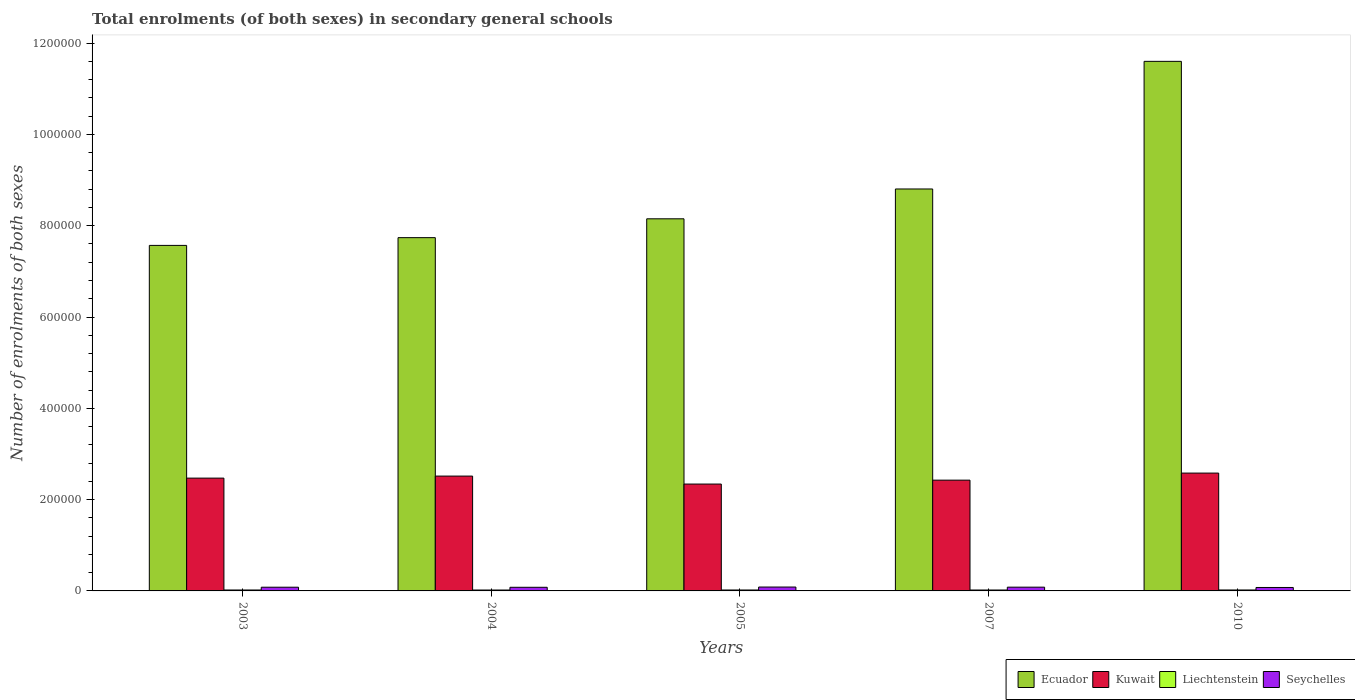How many different coloured bars are there?
Provide a short and direct response. 4. How many groups of bars are there?
Offer a very short reply. 5. Are the number of bars per tick equal to the number of legend labels?
Your response must be concise. Yes. How many bars are there on the 5th tick from the right?
Offer a terse response. 4. What is the label of the 2nd group of bars from the left?
Provide a succinct answer. 2004. In how many cases, is the number of bars for a given year not equal to the number of legend labels?
Give a very brief answer. 0. What is the number of enrolments in secondary schools in Kuwait in 2005?
Offer a terse response. 2.34e+05. Across all years, what is the maximum number of enrolments in secondary schools in Kuwait?
Make the answer very short. 2.58e+05. Across all years, what is the minimum number of enrolments in secondary schools in Seychelles?
Your answer should be compact. 7554. In which year was the number of enrolments in secondary schools in Seychelles maximum?
Offer a very short reply. 2005. In which year was the number of enrolments in secondary schools in Ecuador minimum?
Provide a short and direct response. 2003. What is the total number of enrolments in secondary schools in Liechtenstein in the graph?
Make the answer very short. 1.01e+04. What is the difference between the number of enrolments in secondary schools in Ecuador in 2003 and that in 2010?
Ensure brevity in your answer.  -4.03e+05. What is the difference between the number of enrolments in secondary schools in Kuwait in 2010 and the number of enrolments in secondary schools in Seychelles in 2005?
Make the answer very short. 2.50e+05. What is the average number of enrolments in secondary schools in Seychelles per year?
Offer a very short reply. 8076.2. In the year 2010, what is the difference between the number of enrolments in secondary schools in Ecuador and number of enrolments in secondary schools in Kuwait?
Keep it short and to the point. 9.02e+05. What is the ratio of the number of enrolments in secondary schools in Liechtenstein in 2003 to that in 2005?
Keep it short and to the point. 0.99. Is the difference between the number of enrolments in secondary schools in Ecuador in 2005 and 2007 greater than the difference between the number of enrolments in secondary schools in Kuwait in 2005 and 2007?
Your response must be concise. No. What is the difference between the highest and the second highest number of enrolments in secondary schools in Liechtenstein?
Your answer should be very brief. 19. What is the difference between the highest and the lowest number of enrolments in secondary schools in Ecuador?
Make the answer very short. 4.03e+05. Is the sum of the number of enrolments in secondary schools in Liechtenstein in 2003 and 2005 greater than the maximum number of enrolments in secondary schools in Kuwait across all years?
Keep it short and to the point. No. Is it the case that in every year, the sum of the number of enrolments in secondary schools in Ecuador and number of enrolments in secondary schools in Seychelles is greater than the sum of number of enrolments in secondary schools in Liechtenstein and number of enrolments in secondary schools in Kuwait?
Keep it short and to the point. Yes. What does the 4th bar from the left in 2010 represents?
Offer a terse response. Seychelles. What does the 2nd bar from the right in 2005 represents?
Give a very brief answer. Liechtenstein. Are all the bars in the graph horizontal?
Your response must be concise. No. Does the graph contain grids?
Ensure brevity in your answer.  No. Where does the legend appear in the graph?
Offer a terse response. Bottom right. How many legend labels are there?
Provide a short and direct response. 4. How are the legend labels stacked?
Give a very brief answer. Horizontal. What is the title of the graph?
Make the answer very short. Total enrolments (of both sexes) in secondary general schools. What is the label or title of the X-axis?
Offer a terse response. Years. What is the label or title of the Y-axis?
Make the answer very short. Number of enrolments of both sexes. What is the Number of enrolments of both sexes of Ecuador in 2003?
Keep it short and to the point. 7.57e+05. What is the Number of enrolments of both sexes in Kuwait in 2003?
Provide a short and direct response. 2.47e+05. What is the Number of enrolments of both sexes of Liechtenstein in 2003?
Make the answer very short. 2028. What is the Number of enrolments of both sexes in Seychelles in 2003?
Offer a very short reply. 8137. What is the Number of enrolments of both sexes of Ecuador in 2004?
Make the answer very short. 7.74e+05. What is the Number of enrolments of both sexes in Kuwait in 2004?
Give a very brief answer. 2.52e+05. What is the Number of enrolments of both sexes in Liechtenstein in 2004?
Your response must be concise. 1975. What is the Number of enrolments of both sexes in Seychelles in 2004?
Your response must be concise. 7962. What is the Number of enrolments of both sexes in Ecuador in 2005?
Ensure brevity in your answer.  8.15e+05. What is the Number of enrolments of both sexes in Kuwait in 2005?
Your response must be concise. 2.34e+05. What is the Number of enrolments of both sexes in Liechtenstein in 2005?
Offer a very short reply. 2048. What is the Number of enrolments of both sexes in Seychelles in 2005?
Offer a terse response. 8501. What is the Number of enrolments of both sexes in Ecuador in 2007?
Provide a succinct answer. 8.80e+05. What is the Number of enrolments of both sexes in Kuwait in 2007?
Your answer should be compact. 2.43e+05. What is the Number of enrolments of both sexes of Liechtenstein in 2007?
Your answer should be compact. 2014. What is the Number of enrolments of both sexes of Seychelles in 2007?
Offer a very short reply. 8227. What is the Number of enrolments of both sexes of Ecuador in 2010?
Provide a succinct answer. 1.16e+06. What is the Number of enrolments of both sexes of Kuwait in 2010?
Your answer should be compact. 2.58e+05. What is the Number of enrolments of both sexes of Liechtenstein in 2010?
Give a very brief answer. 2067. What is the Number of enrolments of both sexes in Seychelles in 2010?
Your answer should be compact. 7554. Across all years, what is the maximum Number of enrolments of both sexes of Ecuador?
Keep it short and to the point. 1.16e+06. Across all years, what is the maximum Number of enrolments of both sexes in Kuwait?
Your response must be concise. 2.58e+05. Across all years, what is the maximum Number of enrolments of both sexes in Liechtenstein?
Provide a succinct answer. 2067. Across all years, what is the maximum Number of enrolments of both sexes in Seychelles?
Your answer should be very brief. 8501. Across all years, what is the minimum Number of enrolments of both sexes in Ecuador?
Provide a succinct answer. 7.57e+05. Across all years, what is the minimum Number of enrolments of both sexes of Kuwait?
Make the answer very short. 2.34e+05. Across all years, what is the minimum Number of enrolments of both sexes of Liechtenstein?
Offer a terse response. 1975. Across all years, what is the minimum Number of enrolments of both sexes of Seychelles?
Offer a very short reply. 7554. What is the total Number of enrolments of both sexes of Ecuador in the graph?
Give a very brief answer. 4.39e+06. What is the total Number of enrolments of both sexes of Kuwait in the graph?
Provide a succinct answer. 1.23e+06. What is the total Number of enrolments of both sexes in Liechtenstein in the graph?
Give a very brief answer. 1.01e+04. What is the total Number of enrolments of both sexes of Seychelles in the graph?
Your answer should be compact. 4.04e+04. What is the difference between the Number of enrolments of both sexes in Ecuador in 2003 and that in 2004?
Keep it short and to the point. -1.70e+04. What is the difference between the Number of enrolments of both sexes in Kuwait in 2003 and that in 2004?
Keep it short and to the point. -4450. What is the difference between the Number of enrolments of both sexes of Liechtenstein in 2003 and that in 2004?
Keep it short and to the point. 53. What is the difference between the Number of enrolments of both sexes of Seychelles in 2003 and that in 2004?
Make the answer very short. 175. What is the difference between the Number of enrolments of both sexes in Ecuador in 2003 and that in 2005?
Keep it short and to the point. -5.83e+04. What is the difference between the Number of enrolments of both sexes in Kuwait in 2003 and that in 2005?
Provide a short and direct response. 1.30e+04. What is the difference between the Number of enrolments of both sexes in Liechtenstein in 2003 and that in 2005?
Ensure brevity in your answer.  -20. What is the difference between the Number of enrolments of both sexes of Seychelles in 2003 and that in 2005?
Your answer should be very brief. -364. What is the difference between the Number of enrolments of both sexes of Ecuador in 2003 and that in 2007?
Provide a short and direct response. -1.24e+05. What is the difference between the Number of enrolments of both sexes of Kuwait in 2003 and that in 2007?
Provide a succinct answer. 4472. What is the difference between the Number of enrolments of both sexes in Seychelles in 2003 and that in 2007?
Your answer should be very brief. -90. What is the difference between the Number of enrolments of both sexes of Ecuador in 2003 and that in 2010?
Your answer should be compact. -4.03e+05. What is the difference between the Number of enrolments of both sexes of Kuwait in 2003 and that in 2010?
Ensure brevity in your answer.  -1.10e+04. What is the difference between the Number of enrolments of both sexes of Liechtenstein in 2003 and that in 2010?
Make the answer very short. -39. What is the difference between the Number of enrolments of both sexes in Seychelles in 2003 and that in 2010?
Your answer should be very brief. 583. What is the difference between the Number of enrolments of both sexes in Ecuador in 2004 and that in 2005?
Your answer should be compact. -4.13e+04. What is the difference between the Number of enrolments of both sexes in Kuwait in 2004 and that in 2005?
Ensure brevity in your answer.  1.75e+04. What is the difference between the Number of enrolments of both sexes in Liechtenstein in 2004 and that in 2005?
Your response must be concise. -73. What is the difference between the Number of enrolments of both sexes in Seychelles in 2004 and that in 2005?
Offer a very short reply. -539. What is the difference between the Number of enrolments of both sexes of Ecuador in 2004 and that in 2007?
Provide a succinct answer. -1.07e+05. What is the difference between the Number of enrolments of both sexes of Kuwait in 2004 and that in 2007?
Provide a short and direct response. 8922. What is the difference between the Number of enrolments of both sexes of Liechtenstein in 2004 and that in 2007?
Give a very brief answer. -39. What is the difference between the Number of enrolments of both sexes in Seychelles in 2004 and that in 2007?
Provide a short and direct response. -265. What is the difference between the Number of enrolments of both sexes in Ecuador in 2004 and that in 2010?
Keep it short and to the point. -3.86e+05. What is the difference between the Number of enrolments of both sexes of Kuwait in 2004 and that in 2010?
Your response must be concise. -6545. What is the difference between the Number of enrolments of both sexes of Liechtenstein in 2004 and that in 2010?
Offer a very short reply. -92. What is the difference between the Number of enrolments of both sexes in Seychelles in 2004 and that in 2010?
Your response must be concise. 408. What is the difference between the Number of enrolments of both sexes of Ecuador in 2005 and that in 2007?
Your answer should be very brief. -6.53e+04. What is the difference between the Number of enrolments of both sexes of Kuwait in 2005 and that in 2007?
Keep it short and to the point. -8558. What is the difference between the Number of enrolments of both sexes of Liechtenstein in 2005 and that in 2007?
Provide a short and direct response. 34. What is the difference between the Number of enrolments of both sexes in Seychelles in 2005 and that in 2007?
Ensure brevity in your answer.  274. What is the difference between the Number of enrolments of both sexes in Ecuador in 2005 and that in 2010?
Ensure brevity in your answer.  -3.45e+05. What is the difference between the Number of enrolments of both sexes in Kuwait in 2005 and that in 2010?
Provide a short and direct response. -2.40e+04. What is the difference between the Number of enrolments of both sexes of Liechtenstein in 2005 and that in 2010?
Your response must be concise. -19. What is the difference between the Number of enrolments of both sexes in Seychelles in 2005 and that in 2010?
Ensure brevity in your answer.  947. What is the difference between the Number of enrolments of both sexes of Ecuador in 2007 and that in 2010?
Make the answer very short. -2.80e+05. What is the difference between the Number of enrolments of both sexes in Kuwait in 2007 and that in 2010?
Provide a short and direct response. -1.55e+04. What is the difference between the Number of enrolments of both sexes of Liechtenstein in 2007 and that in 2010?
Offer a very short reply. -53. What is the difference between the Number of enrolments of both sexes in Seychelles in 2007 and that in 2010?
Your answer should be very brief. 673. What is the difference between the Number of enrolments of both sexes of Ecuador in 2003 and the Number of enrolments of both sexes of Kuwait in 2004?
Your answer should be compact. 5.05e+05. What is the difference between the Number of enrolments of both sexes in Ecuador in 2003 and the Number of enrolments of both sexes in Liechtenstein in 2004?
Give a very brief answer. 7.55e+05. What is the difference between the Number of enrolments of both sexes in Ecuador in 2003 and the Number of enrolments of both sexes in Seychelles in 2004?
Give a very brief answer. 7.49e+05. What is the difference between the Number of enrolments of both sexes in Kuwait in 2003 and the Number of enrolments of both sexes in Liechtenstein in 2004?
Keep it short and to the point. 2.45e+05. What is the difference between the Number of enrolments of both sexes in Kuwait in 2003 and the Number of enrolments of both sexes in Seychelles in 2004?
Provide a short and direct response. 2.39e+05. What is the difference between the Number of enrolments of both sexes of Liechtenstein in 2003 and the Number of enrolments of both sexes of Seychelles in 2004?
Give a very brief answer. -5934. What is the difference between the Number of enrolments of both sexes of Ecuador in 2003 and the Number of enrolments of both sexes of Kuwait in 2005?
Offer a terse response. 5.23e+05. What is the difference between the Number of enrolments of both sexes of Ecuador in 2003 and the Number of enrolments of both sexes of Liechtenstein in 2005?
Keep it short and to the point. 7.55e+05. What is the difference between the Number of enrolments of both sexes in Ecuador in 2003 and the Number of enrolments of both sexes in Seychelles in 2005?
Give a very brief answer. 7.48e+05. What is the difference between the Number of enrolments of both sexes of Kuwait in 2003 and the Number of enrolments of both sexes of Liechtenstein in 2005?
Provide a succinct answer. 2.45e+05. What is the difference between the Number of enrolments of both sexes of Kuwait in 2003 and the Number of enrolments of both sexes of Seychelles in 2005?
Your answer should be very brief. 2.39e+05. What is the difference between the Number of enrolments of both sexes of Liechtenstein in 2003 and the Number of enrolments of both sexes of Seychelles in 2005?
Your response must be concise. -6473. What is the difference between the Number of enrolments of both sexes in Ecuador in 2003 and the Number of enrolments of both sexes in Kuwait in 2007?
Ensure brevity in your answer.  5.14e+05. What is the difference between the Number of enrolments of both sexes of Ecuador in 2003 and the Number of enrolments of both sexes of Liechtenstein in 2007?
Give a very brief answer. 7.55e+05. What is the difference between the Number of enrolments of both sexes of Ecuador in 2003 and the Number of enrolments of both sexes of Seychelles in 2007?
Offer a very short reply. 7.49e+05. What is the difference between the Number of enrolments of both sexes in Kuwait in 2003 and the Number of enrolments of both sexes in Liechtenstein in 2007?
Ensure brevity in your answer.  2.45e+05. What is the difference between the Number of enrolments of both sexes in Kuwait in 2003 and the Number of enrolments of both sexes in Seychelles in 2007?
Keep it short and to the point. 2.39e+05. What is the difference between the Number of enrolments of both sexes of Liechtenstein in 2003 and the Number of enrolments of both sexes of Seychelles in 2007?
Ensure brevity in your answer.  -6199. What is the difference between the Number of enrolments of both sexes in Ecuador in 2003 and the Number of enrolments of both sexes in Kuwait in 2010?
Your answer should be compact. 4.99e+05. What is the difference between the Number of enrolments of both sexes of Ecuador in 2003 and the Number of enrolments of both sexes of Liechtenstein in 2010?
Keep it short and to the point. 7.55e+05. What is the difference between the Number of enrolments of both sexes in Ecuador in 2003 and the Number of enrolments of both sexes in Seychelles in 2010?
Provide a short and direct response. 7.49e+05. What is the difference between the Number of enrolments of both sexes of Kuwait in 2003 and the Number of enrolments of both sexes of Liechtenstein in 2010?
Your answer should be compact. 2.45e+05. What is the difference between the Number of enrolments of both sexes of Kuwait in 2003 and the Number of enrolments of both sexes of Seychelles in 2010?
Provide a succinct answer. 2.40e+05. What is the difference between the Number of enrolments of both sexes in Liechtenstein in 2003 and the Number of enrolments of both sexes in Seychelles in 2010?
Ensure brevity in your answer.  -5526. What is the difference between the Number of enrolments of both sexes in Ecuador in 2004 and the Number of enrolments of both sexes in Kuwait in 2005?
Provide a succinct answer. 5.40e+05. What is the difference between the Number of enrolments of both sexes in Ecuador in 2004 and the Number of enrolments of both sexes in Liechtenstein in 2005?
Offer a very short reply. 7.72e+05. What is the difference between the Number of enrolments of both sexes of Ecuador in 2004 and the Number of enrolments of both sexes of Seychelles in 2005?
Provide a short and direct response. 7.65e+05. What is the difference between the Number of enrolments of both sexes in Kuwait in 2004 and the Number of enrolments of both sexes in Liechtenstein in 2005?
Provide a short and direct response. 2.50e+05. What is the difference between the Number of enrolments of both sexes of Kuwait in 2004 and the Number of enrolments of both sexes of Seychelles in 2005?
Provide a succinct answer. 2.43e+05. What is the difference between the Number of enrolments of both sexes in Liechtenstein in 2004 and the Number of enrolments of both sexes in Seychelles in 2005?
Give a very brief answer. -6526. What is the difference between the Number of enrolments of both sexes in Ecuador in 2004 and the Number of enrolments of both sexes in Kuwait in 2007?
Offer a terse response. 5.31e+05. What is the difference between the Number of enrolments of both sexes in Ecuador in 2004 and the Number of enrolments of both sexes in Liechtenstein in 2007?
Offer a very short reply. 7.72e+05. What is the difference between the Number of enrolments of both sexes in Ecuador in 2004 and the Number of enrolments of both sexes in Seychelles in 2007?
Your answer should be compact. 7.66e+05. What is the difference between the Number of enrolments of both sexes in Kuwait in 2004 and the Number of enrolments of both sexes in Liechtenstein in 2007?
Ensure brevity in your answer.  2.50e+05. What is the difference between the Number of enrolments of both sexes of Kuwait in 2004 and the Number of enrolments of both sexes of Seychelles in 2007?
Your answer should be very brief. 2.43e+05. What is the difference between the Number of enrolments of both sexes in Liechtenstein in 2004 and the Number of enrolments of both sexes in Seychelles in 2007?
Offer a terse response. -6252. What is the difference between the Number of enrolments of both sexes of Ecuador in 2004 and the Number of enrolments of both sexes of Kuwait in 2010?
Offer a terse response. 5.16e+05. What is the difference between the Number of enrolments of both sexes in Ecuador in 2004 and the Number of enrolments of both sexes in Liechtenstein in 2010?
Ensure brevity in your answer.  7.72e+05. What is the difference between the Number of enrolments of both sexes in Ecuador in 2004 and the Number of enrolments of both sexes in Seychelles in 2010?
Make the answer very short. 7.66e+05. What is the difference between the Number of enrolments of both sexes of Kuwait in 2004 and the Number of enrolments of both sexes of Liechtenstein in 2010?
Ensure brevity in your answer.  2.49e+05. What is the difference between the Number of enrolments of both sexes of Kuwait in 2004 and the Number of enrolments of both sexes of Seychelles in 2010?
Provide a succinct answer. 2.44e+05. What is the difference between the Number of enrolments of both sexes of Liechtenstein in 2004 and the Number of enrolments of both sexes of Seychelles in 2010?
Offer a very short reply. -5579. What is the difference between the Number of enrolments of both sexes of Ecuador in 2005 and the Number of enrolments of both sexes of Kuwait in 2007?
Your answer should be compact. 5.72e+05. What is the difference between the Number of enrolments of both sexes of Ecuador in 2005 and the Number of enrolments of both sexes of Liechtenstein in 2007?
Provide a short and direct response. 8.13e+05. What is the difference between the Number of enrolments of both sexes of Ecuador in 2005 and the Number of enrolments of both sexes of Seychelles in 2007?
Ensure brevity in your answer.  8.07e+05. What is the difference between the Number of enrolments of both sexes in Kuwait in 2005 and the Number of enrolments of both sexes in Liechtenstein in 2007?
Offer a terse response. 2.32e+05. What is the difference between the Number of enrolments of both sexes in Kuwait in 2005 and the Number of enrolments of both sexes in Seychelles in 2007?
Ensure brevity in your answer.  2.26e+05. What is the difference between the Number of enrolments of both sexes in Liechtenstein in 2005 and the Number of enrolments of both sexes in Seychelles in 2007?
Your answer should be compact. -6179. What is the difference between the Number of enrolments of both sexes in Ecuador in 2005 and the Number of enrolments of both sexes in Kuwait in 2010?
Offer a very short reply. 5.57e+05. What is the difference between the Number of enrolments of both sexes of Ecuador in 2005 and the Number of enrolments of both sexes of Liechtenstein in 2010?
Give a very brief answer. 8.13e+05. What is the difference between the Number of enrolments of both sexes in Ecuador in 2005 and the Number of enrolments of both sexes in Seychelles in 2010?
Offer a terse response. 8.08e+05. What is the difference between the Number of enrolments of both sexes of Kuwait in 2005 and the Number of enrolments of both sexes of Liechtenstein in 2010?
Offer a terse response. 2.32e+05. What is the difference between the Number of enrolments of both sexes of Kuwait in 2005 and the Number of enrolments of both sexes of Seychelles in 2010?
Offer a terse response. 2.27e+05. What is the difference between the Number of enrolments of both sexes of Liechtenstein in 2005 and the Number of enrolments of both sexes of Seychelles in 2010?
Provide a succinct answer. -5506. What is the difference between the Number of enrolments of both sexes of Ecuador in 2007 and the Number of enrolments of both sexes of Kuwait in 2010?
Ensure brevity in your answer.  6.22e+05. What is the difference between the Number of enrolments of both sexes in Ecuador in 2007 and the Number of enrolments of both sexes in Liechtenstein in 2010?
Provide a short and direct response. 8.78e+05. What is the difference between the Number of enrolments of both sexes in Ecuador in 2007 and the Number of enrolments of both sexes in Seychelles in 2010?
Ensure brevity in your answer.  8.73e+05. What is the difference between the Number of enrolments of both sexes in Kuwait in 2007 and the Number of enrolments of both sexes in Liechtenstein in 2010?
Keep it short and to the point. 2.41e+05. What is the difference between the Number of enrolments of both sexes in Kuwait in 2007 and the Number of enrolments of both sexes in Seychelles in 2010?
Your answer should be very brief. 2.35e+05. What is the difference between the Number of enrolments of both sexes in Liechtenstein in 2007 and the Number of enrolments of both sexes in Seychelles in 2010?
Your response must be concise. -5540. What is the average Number of enrolments of both sexes in Ecuador per year?
Keep it short and to the point. 8.77e+05. What is the average Number of enrolments of both sexes of Kuwait per year?
Offer a very short reply. 2.47e+05. What is the average Number of enrolments of both sexes of Liechtenstein per year?
Your answer should be compact. 2026.4. What is the average Number of enrolments of both sexes of Seychelles per year?
Your response must be concise. 8076.2. In the year 2003, what is the difference between the Number of enrolments of both sexes of Ecuador and Number of enrolments of both sexes of Kuwait?
Your response must be concise. 5.10e+05. In the year 2003, what is the difference between the Number of enrolments of both sexes of Ecuador and Number of enrolments of both sexes of Liechtenstein?
Your answer should be very brief. 7.55e+05. In the year 2003, what is the difference between the Number of enrolments of both sexes of Ecuador and Number of enrolments of both sexes of Seychelles?
Provide a succinct answer. 7.49e+05. In the year 2003, what is the difference between the Number of enrolments of both sexes in Kuwait and Number of enrolments of both sexes in Liechtenstein?
Your answer should be compact. 2.45e+05. In the year 2003, what is the difference between the Number of enrolments of both sexes in Kuwait and Number of enrolments of both sexes in Seychelles?
Give a very brief answer. 2.39e+05. In the year 2003, what is the difference between the Number of enrolments of both sexes in Liechtenstein and Number of enrolments of both sexes in Seychelles?
Your response must be concise. -6109. In the year 2004, what is the difference between the Number of enrolments of both sexes in Ecuador and Number of enrolments of both sexes in Kuwait?
Keep it short and to the point. 5.22e+05. In the year 2004, what is the difference between the Number of enrolments of both sexes of Ecuador and Number of enrolments of both sexes of Liechtenstein?
Make the answer very short. 7.72e+05. In the year 2004, what is the difference between the Number of enrolments of both sexes of Ecuador and Number of enrolments of both sexes of Seychelles?
Offer a terse response. 7.66e+05. In the year 2004, what is the difference between the Number of enrolments of both sexes of Kuwait and Number of enrolments of both sexes of Liechtenstein?
Ensure brevity in your answer.  2.50e+05. In the year 2004, what is the difference between the Number of enrolments of both sexes of Kuwait and Number of enrolments of both sexes of Seychelles?
Offer a terse response. 2.44e+05. In the year 2004, what is the difference between the Number of enrolments of both sexes in Liechtenstein and Number of enrolments of both sexes in Seychelles?
Ensure brevity in your answer.  -5987. In the year 2005, what is the difference between the Number of enrolments of both sexes in Ecuador and Number of enrolments of both sexes in Kuwait?
Your answer should be very brief. 5.81e+05. In the year 2005, what is the difference between the Number of enrolments of both sexes of Ecuador and Number of enrolments of both sexes of Liechtenstein?
Provide a short and direct response. 8.13e+05. In the year 2005, what is the difference between the Number of enrolments of both sexes in Ecuador and Number of enrolments of both sexes in Seychelles?
Make the answer very short. 8.07e+05. In the year 2005, what is the difference between the Number of enrolments of both sexes of Kuwait and Number of enrolments of both sexes of Liechtenstein?
Ensure brevity in your answer.  2.32e+05. In the year 2005, what is the difference between the Number of enrolments of both sexes in Kuwait and Number of enrolments of both sexes in Seychelles?
Offer a terse response. 2.26e+05. In the year 2005, what is the difference between the Number of enrolments of both sexes in Liechtenstein and Number of enrolments of both sexes in Seychelles?
Your answer should be very brief. -6453. In the year 2007, what is the difference between the Number of enrolments of both sexes in Ecuador and Number of enrolments of both sexes in Kuwait?
Give a very brief answer. 6.38e+05. In the year 2007, what is the difference between the Number of enrolments of both sexes in Ecuador and Number of enrolments of both sexes in Liechtenstein?
Give a very brief answer. 8.78e+05. In the year 2007, what is the difference between the Number of enrolments of both sexes of Ecuador and Number of enrolments of both sexes of Seychelles?
Give a very brief answer. 8.72e+05. In the year 2007, what is the difference between the Number of enrolments of both sexes of Kuwait and Number of enrolments of both sexes of Liechtenstein?
Your response must be concise. 2.41e+05. In the year 2007, what is the difference between the Number of enrolments of both sexes in Kuwait and Number of enrolments of both sexes in Seychelles?
Ensure brevity in your answer.  2.34e+05. In the year 2007, what is the difference between the Number of enrolments of both sexes in Liechtenstein and Number of enrolments of both sexes in Seychelles?
Your answer should be compact. -6213. In the year 2010, what is the difference between the Number of enrolments of both sexes of Ecuador and Number of enrolments of both sexes of Kuwait?
Keep it short and to the point. 9.02e+05. In the year 2010, what is the difference between the Number of enrolments of both sexes of Ecuador and Number of enrolments of both sexes of Liechtenstein?
Provide a short and direct response. 1.16e+06. In the year 2010, what is the difference between the Number of enrolments of both sexes in Ecuador and Number of enrolments of both sexes in Seychelles?
Provide a short and direct response. 1.15e+06. In the year 2010, what is the difference between the Number of enrolments of both sexes of Kuwait and Number of enrolments of both sexes of Liechtenstein?
Provide a short and direct response. 2.56e+05. In the year 2010, what is the difference between the Number of enrolments of both sexes in Kuwait and Number of enrolments of both sexes in Seychelles?
Offer a very short reply. 2.51e+05. In the year 2010, what is the difference between the Number of enrolments of both sexes in Liechtenstein and Number of enrolments of both sexes in Seychelles?
Provide a short and direct response. -5487. What is the ratio of the Number of enrolments of both sexes in Kuwait in 2003 to that in 2004?
Offer a terse response. 0.98. What is the ratio of the Number of enrolments of both sexes in Liechtenstein in 2003 to that in 2004?
Your answer should be compact. 1.03. What is the ratio of the Number of enrolments of both sexes in Seychelles in 2003 to that in 2004?
Offer a terse response. 1.02. What is the ratio of the Number of enrolments of both sexes of Ecuador in 2003 to that in 2005?
Your answer should be compact. 0.93. What is the ratio of the Number of enrolments of both sexes in Kuwait in 2003 to that in 2005?
Keep it short and to the point. 1.06. What is the ratio of the Number of enrolments of both sexes of Liechtenstein in 2003 to that in 2005?
Offer a very short reply. 0.99. What is the ratio of the Number of enrolments of both sexes of Seychelles in 2003 to that in 2005?
Your answer should be very brief. 0.96. What is the ratio of the Number of enrolments of both sexes of Ecuador in 2003 to that in 2007?
Give a very brief answer. 0.86. What is the ratio of the Number of enrolments of both sexes of Kuwait in 2003 to that in 2007?
Keep it short and to the point. 1.02. What is the ratio of the Number of enrolments of both sexes of Seychelles in 2003 to that in 2007?
Your answer should be very brief. 0.99. What is the ratio of the Number of enrolments of both sexes in Ecuador in 2003 to that in 2010?
Offer a very short reply. 0.65. What is the ratio of the Number of enrolments of both sexes of Kuwait in 2003 to that in 2010?
Ensure brevity in your answer.  0.96. What is the ratio of the Number of enrolments of both sexes of Liechtenstein in 2003 to that in 2010?
Your answer should be compact. 0.98. What is the ratio of the Number of enrolments of both sexes of Seychelles in 2003 to that in 2010?
Offer a very short reply. 1.08. What is the ratio of the Number of enrolments of both sexes of Ecuador in 2004 to that in 2005?
Keep it short and to the point. 0.95. What is the ratio of the Number of enrolments of both sexes in Kuwait in 2004 to that in 2005?
Ensure brevity in your answer.  1.07. What is the ratio of the Number of enrolments of both sexes in Liechtenstein in 2004 to that in 2005?
Offer a very short reply. 0.96. What is the ratio of the Number of enrolments of both sexes in Seychelles in 2004 to that in 2005?
Keep it short and to the point. 0.94. What is the ratio of the Number of enrolments of both sexes in Ecuador in 2004 to that in 2007?
Your answer should be compact. 0.88. What is the ratio of the Number of enrolments of both sexes in Kuwait in 2004 to that in 2007?
Your answer should be very brief. 1.04. What is the ratio of the Number of enrolments of both sexes of Liechtenstein in 2004 to that in 2007?
Make the answer very short. 0.98. What is the ratio of the Number of enrolments of both sexes in Seychelles in 2004 to that in 2007?
Make the answer very short. 0.97. What is the ratio of the Number of enrolments of both sexes of Ecuador in 2004 to that in 2010?
Your answer should be very brief. 0.67. What is the ratio of the Number of enrolments of both sexes of Kuwait in 2004 to that in 2010?
Give a very brief answer. 0.97. What is the ratio of the Number of enrolments of both sexes of Liechtenstein in 2004 to that in 2010?
Your answer should be compact. 0.96. What is the ratio of the Number of enrolments of both sexes in Seychelles in 2004 to that in 2010?
Offer a terse response. 1.05. What is the ratio of the Number of enrolments of both sexes of Ecuador in 2005 to that in 2007?
Provide a short and direct response. 0.93. What is the ratio of the Number of enrolments of both sexes of Kuwait in 2005 to that in 2007?
Your answer should be compact. 0.96. What is the ratio of the Number of enrolments of both sexes of Liechtenstein in 2005 to that in 2007?
Keep it short and to the point. 1.02. What is the ratio of the Number of enrolments of both sexes of Seychelles in 2005 to that in 2007?
Your answer should be very brief. 1.03. What is the ratio of the Number of enrolments of both sexes in Ecuador in 2005 to that in 2010?
Provide a short and direct response. 0.7. What is the ratio of the Number of enrolments of both sexes of Kuwait in 2005 to that in 2010?
Offer a very short reply. 0.91. What is the ratio of the Number of enrolments of both sexes of Seychelles in 2005 to that in 2010?
Provide a short and direct response. 1.13. What is the ratio of the Number of enrolments of both sexes of Ecuador in 2007 to that in 2010?
Make the answer very short. 0.76. What is the ratio of the Number of enrolments of both sexes in Kuwait in 2007 to that in 2010?
Your response must be concise. 0.94. What is the ratio of the Number of enrolments of both sexes of Liechtenstein in 2007 to that in 2010?
Offer a very short reply. 0.97. What is the ratio of the Number of enrolments of both sexes in Seychelles in 2007 to that in 2010?
Ensure brevity in your answer.  1.09. What is the difference between the highest and the second highest Number of enrolments of both sexes of Ecuador?
Make the answer very short. 2.80e+05. What is the difference between the highest and the second highest Number of enrolments of both sexes of Kuwait?
Your answer should be very brief. 6545. What is the difference between the highest and the second highest Number of enrolments of both sexes of Liechtenstein?
Your answer should be compact. 19. What is the difference between the highest and the second highest Number of enrolments of both sexes of Seychelles?
Your answer should be very brief. 274. What is the difference between the highest and the lowest Number of enrolments of both sexes in Ecuador?
Keep it short and to the point. 4.03e+05. What is the difference between the highest and the lowest Number of enrolments of both sexes of Kuwait?
Keep it short and to the point. 2.40e+04. What is the difference between the highest and the lowest Number of enrolments of both sexes of Liechtenstein?
Ensure brevity in your answer.  92. What is the difference between the highest and the lowest Number of enrolments of both sexes in Seychelles?
Provide a succinct answer. 947. 